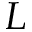<formula> <loc_0><loc_0><loc_500><loc_500>L</formula> 